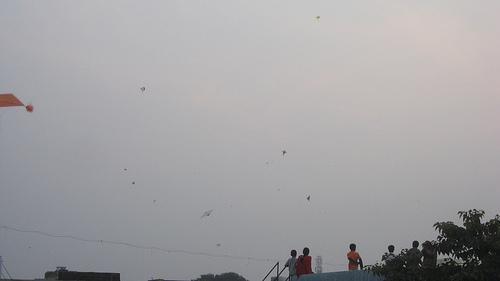How many kids are there?
Give a very brief answer. 6. How many kids are sitting down?
Give a very brief answer. 2. How many kites can you tell are flying?
Give a very brief answer. 5. 